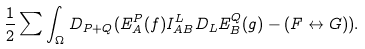<formula> <loc_0><loc_0><loc_500><loc_500>\frac { 1 } { 2 } \sum \int _ { \Omega } D _ { P + Q } ( E _ { A } ^ { P } ( f ) I _ { A B } ^ { L } D _ { L } E _ { B } ^ { Q } ( g ) - ( F \leftrightarrow G ) ) .</formula> 